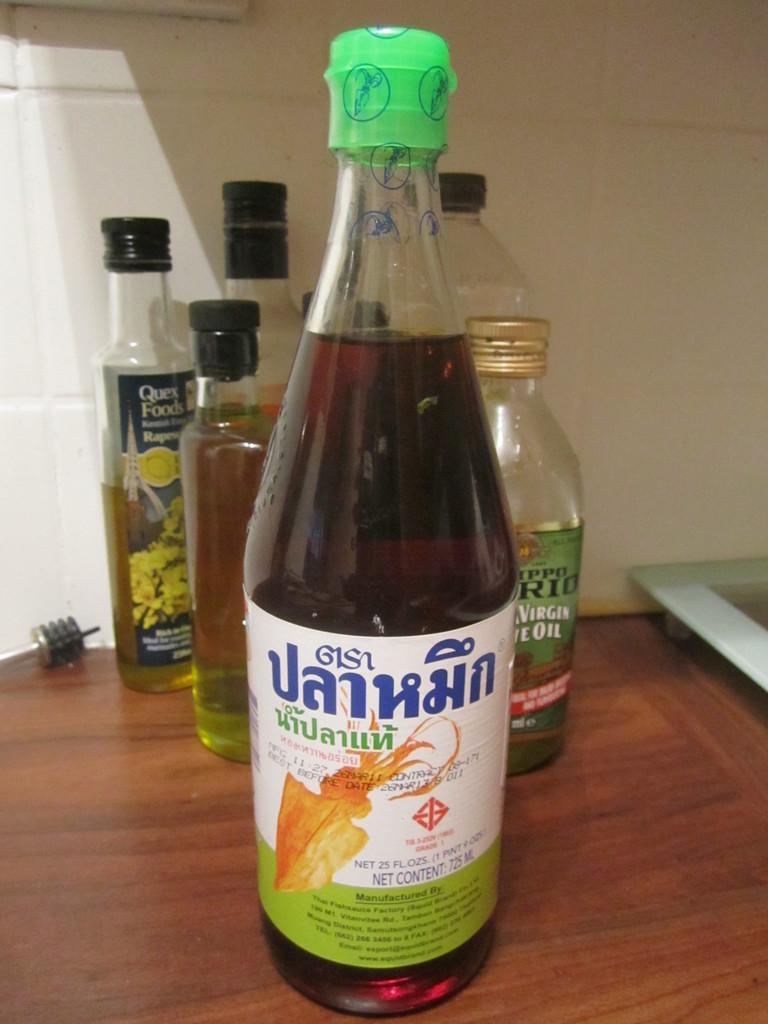Describe this image in one or two sentences. In this picture there are many bottles. In the foreground there is bottle having green cap is there. All these bottles are on table. in the background there is a white wall. 